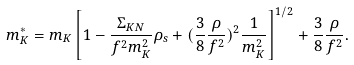Convert formula to latex. <formula><loc_0><loc_0><loc_500><loc_500>m _ { K } ^ { * } = m _ { K } \left [ 1 - \frac { \Sigma _ { K N } } { f ^ { 2 } m _ { K } ^ { 2 } } \rho _ { s } + ( \frac { 3 } { 8 } \frac { \rho } { f ^ { 2 } } ) ^ { 2 } \frac { 1 } { m _ { K } ^ { 2 } } \right ] ^ { 1 / 2 } + \frac { 3 } { 8 } \frac { \rho } { f ^ { 2 } } .</formula> 